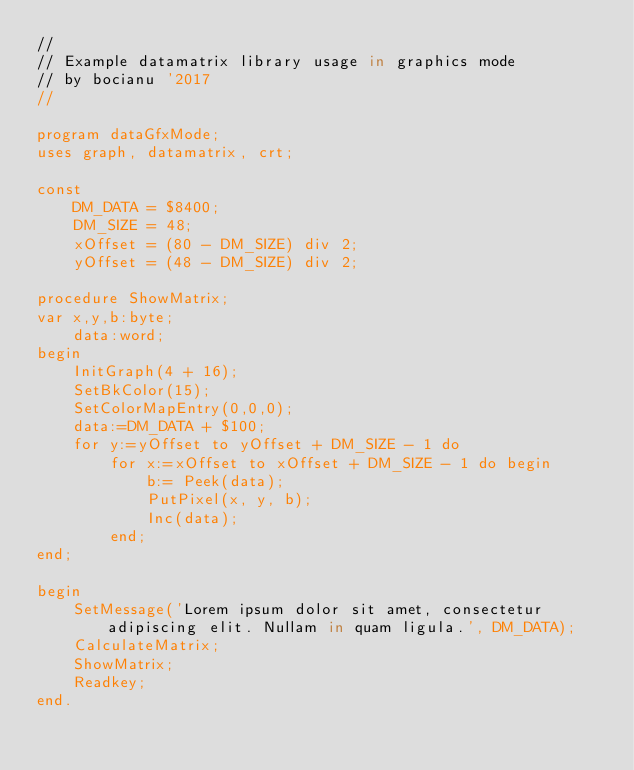Convert code to text. <code><loc_0><loc_0><loc_500><loc_500><_Pascal_>//
// Example datamatrix library usage in graphics mode
// by bocianu '2017
//

program dataGfxMode;
uses graph, datamatrix, crt;

const
    DM_DATA = $8400;
    DM_SIZE = 48;
    xOffset = (80 - DM_SIZE) div 2;
    yOffset = (48 - DM_SIZE) div 2;

procedure ShowMatrix;
var x,y,b:byte;
    data:word;
begin
    InitGraph(4 + 16);
    SetBkColor(15);
    SetColorMapEntry(0,0,0);
    data:=DM_DATA + $100;
    for y:=yOffset to yOffset + DM_SIZE - 1 do
        for x:=xOffset to xOffset + DM_SIZE - 1 do begin
            b:= Peek(data);
            PutPixel(x, y, b);
            Inc(data);
        end;
end;

begin
    SetMessage('Lorem ipsum dolor sit amet, consectetur adipiscing elit. Nullam in quam ligula.', DM_DATA);
    CalculateMatrix;
    ShowMatrix;
    Readkey;
end.
</code> 